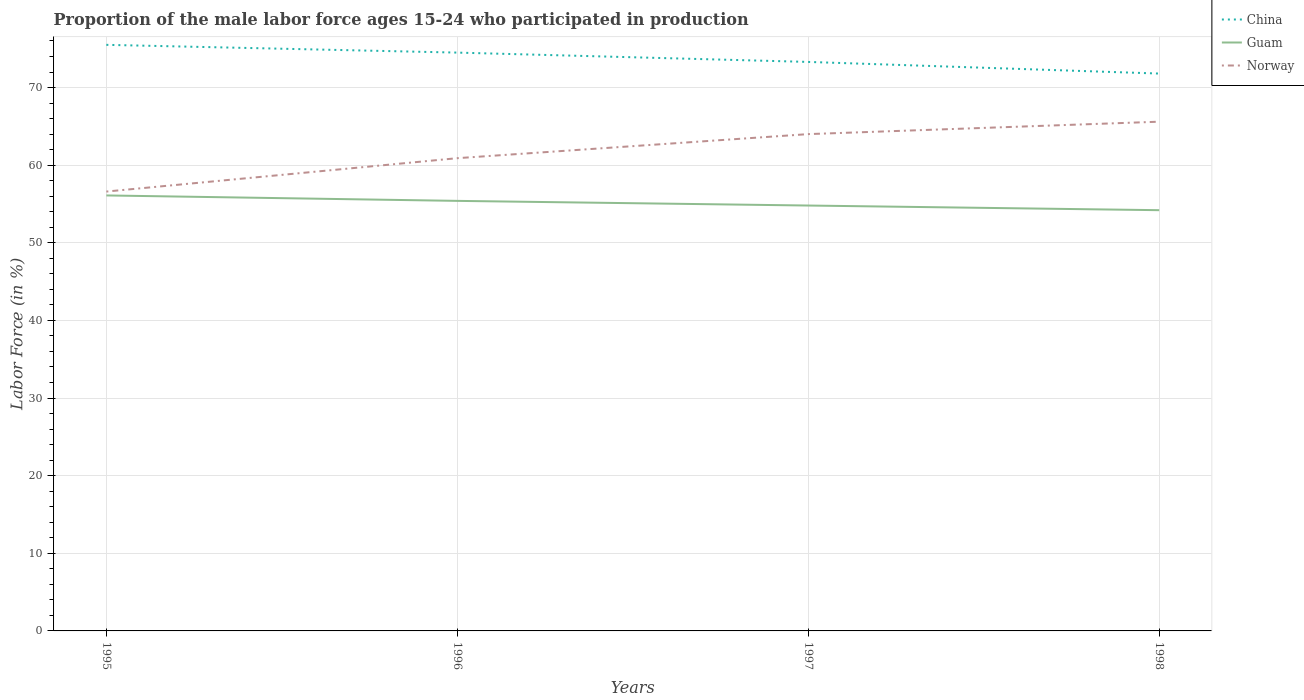How many different coloured lines are there?
Your answer should be very brief. 3. Across all years, what is the maximum proportion of the male labor force who participated in production in China?
Ensure brevity in your answer.  71.8. In which year was the proportion of the male labor force who participated in production in China maximum?
Provide a short and direct response. 1998. What is the total proportion of the male labor force who participated in production in Guam in the graph?
Make the answer very short. 0.6. What is the difference between the highest and the second highest proportion of the male labor force who participated in production in Guam?
Give a very brief answer. 1.9. What is the difference between the highest and the lowest proportion of the male labor force who participated in production in Guam?
Give a very brief answer. 2. How many lines are there?
Your answer should be compact. 3. What is the difference between two consecutive major ticks on the Y-axis?
Keep it short and to the point. 10. Does the graph contain any zero values?
Your answer should be very brief. No. Does the graph contain grids?
Make the answer very short. Yes. How many legend labels are there?
Ensure brevity in your answer.  3. What is the title of the graph?
Make the answer very short. Proportion of the male labor force ages 15-24 who participated in production. What is the label or title of the X-axis?
Your answer should be very brief. Years. What is the label or title of the Y-axis?
Your answer should be compact. Labor Force (in %). What is the Labor Force (in %) of China in 1995?
Keep it short and to the point. 75.5. What is the Labor Force (in %) of Guam in 1995?
Offer a very short reply. 56.1. What is the Labor Force (in %) in Norway in 1995?
Make the answer very short. 56.6. What is the Labor Force (in %) in China in 1996?
Offer a very short reply. 74.5. What is the Labor Force (in %) in Guam in 1996?
Make the answer very short. 55.4. What is the Labor Force (in %) in Norway in 1996?
Provide a short and direct response. 60.9. What is the Labor Force (in %) in China in 1997?
Provide a short and direct response. 73.3. What is the Labor Force (in %) in Guam in 1997?
Offer a terse response. 54.8. What is the Labor Force (in %) of China in 1998?
Keep it short and to the point. 71.8. What is the Labor Force (in %) of Guam in 1998?
Ensure brevity in your answer.  54.2. What is the Labor Force (in %) of Norway in 1998?
Offer a very short reply. 65.6. Across all years, what is the maximum Labor Force (in %) of China?
Your answer should be very brief. 75.5. Across all years, what is the maximum Labor Force (in %) of Guam?
Your answer should be very brief. 56.1. Across all years, what is the maximum Labor Force (in %) of Norway?
Provide a succinct answer. 65.6. Across all years, what is the minimum Labor Force (in %) in China?
Keep it short and to the point. 71.8. Across all years, what is the minimum Labor Force (in %) in Guam?
Offer a terse response. 54.2. Across all years, what is the minimum Labor Force (in %) in Norway?
Your answer should be compact. 56.6. What is the total Labor Force (in %) of China in the graph?
Provide a succinct answer. 295.1. What is the total Labor Force (in %) in Guam in the graph?
Your answer should be compact. 220.5. What is the total Labor Force (in %) of Norway in the graph?
Ensure brevity in your answer.  247.1. What is the difference between the Labor Force (in %) in China in 1995 and that in 1996?
Provide a short and direct response. 1. What is the difference between the Labor Force (in %) in Guam in 1995 and that in 1996?
Your response must be concise. 0.7. What is the difference between the Labor Force (in %) in Norway in 1995 and that in 1996?
Keep it short and to the point. -4.3. What is the difference between the Labor Force (in %) in Guam in 1995 and that in 1997?
Keep it short and to the point. 1.3. What is the difference between the Labor Force (in %) in Norway in 1995 and that in 1997?
Provide a succinct answer. -7.4. What is the difference between the Labor Force (in %) in China in 1995 and that in 1998?
Ensure brevity in your answer.  3.7. What is the difference between the Labor Force (in %) in Guam in 1995 and that in 1998?
Offer a very short reply. 1.9. What is the difference between the Labor Force (in %) of China in 1996 and that in 1997?
Offer a very short reply. 1.2. What is the difference between the Labor Force (in %) in Norway in 1996 and that in 1997?
Make the answer very short. -3.1. What is the difference between the Labor Force (in %) in China in 1996 and that in 1998?
Keep it short and to the point. 2.7. What is the difference between the Labor Force (in %) of Guam in 1996 and that in 1998?
Your response must be concise. 1.2. What is the difference between the Labor Force (in %) of China in 1997 and that in 1998?
Offer a terse response. 1.5. What is the difference between the Labor Force (in %) in Guam in 1997 and that in 1998?
Your answer should be very brief. 0.6. What is the difference between the Labor Force (in %) in Norway in 1997 and that in 1998?
Ensure brevity in your answer.  -1.6. What is the difference between the Labor Force (in %) in China in 1995 and the Labor Force (in %) in Guam in 1996?
Make the answer very short. 20.1. What is the difference between the Labor Force (in %) of China in 1995 and the Labor Force (in %) of Norway in 1996?
Your response must be concise. 14.6. What is the difference between the Labor Force (in %) of Guam in 1995 and the Labor Force (in %) of Norway in 1996?
Give a very brief answer. -4.8. What is the difference between the Labor Force (in %) of China in 1995 and the Labor Force (in %) of Guam in 1997?
Make the answer very short. 20.7. What is the difference between the Labor Force (in %) of Guam in 1995 and the Labor Force (in %) of Norway in 1997?
Your answer should be very brief. -7.9. What is the difference between the Labor Force (in %) in China in 1995 and the Labor Force (in %) in Guam in 1998?
Offer a terse response. 21.3. What is the difference between the Labor Force (in %) of China in 1995 and the Labor Force (in %) of Norway in 1998?
Keep it short and to the point. 9.9. What is the difference between the Labor Force (in %) of Guam in 1995 and the Labor Force (in %) of Norway in 1998?
Your answer should be compact. -9.5. What is the difference between the Labor Force (in %) in China in 1996 and the Labor Force (in %) in Guam in 1997?
Provide a succinct answer. 19.7. What is the difference between the Labor Force (in %) of Guam in 1996 and the Labor Force (in %) of Norway in 1997?
Keep it short and to the point. -8.6. What is the difference between the Labor Force (in %) in China in 1996 and the Labor Force (in %) in Guam in 1998?
Offer a very short reply. 20.3. What is the difference between the Labor Force (in %) in China in 1996 and the Labor Force (in %) in Norway in 1998?
Your response must be concise. 8.9. What is the average Labor Force (in %) of China per year?
Provide a succinct answer. 73.78. What is the average Labor Force (in %) in Guam per year?
Keep it short and to the point. 55.12. What is the average Labor Force (in %) in Norway per year?
Offer a very short reply. 61.77. In the year 1995, what is the difference between the Labor Force (in %) of China and Labor Force (in %) of Norway?
Give a very brief answer. 18.9. In the year 1996, what is the difference between the Labor Force (in %) in China and Labor Force (in %) in Guam?
Keep it short and to the point. 19.1. In the year 1996, what is the difference between the Labor Force (in %) of Guam and Labor Force (in %) of Norway?
Offer a very short reply. -5.5. What is the ratio of the Labor Force (in %) in China in 1995 to that in 1996?
Ensure brevity in your answer.  1.01. What is the ratio of the Labor Force (in %) of Guam in 1995 to that in 1996?
Your response must be concise. 1.01. What is the ratio of the Labor Force (in %) in Norway in 1995 to that in 1996?
Offer a terse response. 0.93. What is the ratio of the Labor Force (in %) in China in 1995 to that in 1997?
Your answer should be compact. 1.03. What is the ratio of the Labor Force (in %) of Guam in 1995 to that in 1997?
Provide a succinct answer. 1.02. What is the ratio of the Labor Force (in %) in Norway in 1995 to that in 1997?
Your answer should be compact. 0.88. What is the ratio of the Labor Force (in %) of China in 1995 to that in 1998?
Give a very brief answer. 1.05. What is the ratio of the Labor Force (in %) in Guam in 1995 to that in 1998?
Provide a succinct answer. 1.04. What is the ratio of the Labor Force (in %) in Norway in 1995 to that in 1998?
Your answer should be very brief. 0.86. What is the ratio of the Labor Force (in %) of China in 1996 to that in 1997?
Offer a very short reply. 1.02. What is the ratio of the Labor Force (in %) in Guam in 1996 to that in 1997?
Keep it short and to the point. 1.01. What is the ratio of the Labor Force (in %) in Norway in 1996 to that in 1997?
Your answer should be very brief. 0.95. What is the ratio of the Labor Force (in %) of China in 1996 to that in 1998?
Your response must be concise. 1.04. What is the ratio of the Labor Force (in %) in Guam in 1996 to that in 1998?
Give a very brief answer. 1.02. What is the ratio of the Labor Force (in %) in Norway in 1996 to that in 1998?
Offer a terse response. 0.93. What is the ratio of the Labor Force (in %) of China in 1997 to that in 1998?
Ensure brevity in your answer.  1.02. What is the ratio of the Labor Force (in %) in Guam in 1997 to that in 1998?
Offer a very short reply. 1.01. What is the ratio of the Labor Force (in %) of Norway in 1997 to that in 1998?
Provide a short and direct response. 0.98. What is the difference between the highest and the second highest Labor Force (in %) of China?
Your answer should be compact. 1. What is the difference between the highest and the second highest Labor Force (in %) of Guam?
Your answer should be compact. 0.7. What is the difference between the highest and the second highest Labor Force (in %) in Norway?
Make the answer very short. 1.6. What is the difference between the highest and the lowest Labor Force (in %) of Guam?
Your response must be concise. 1.9. 